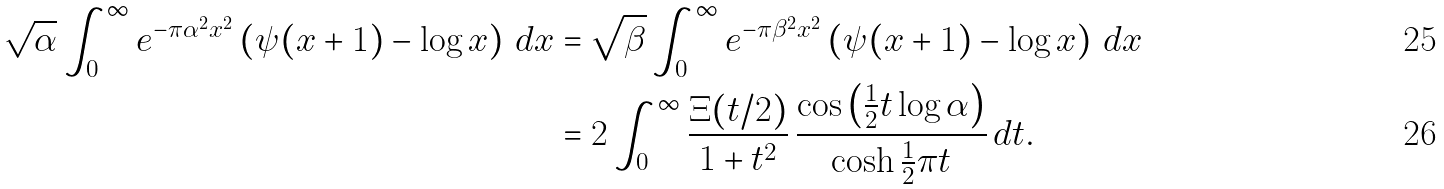Convert formula to latex. <formula><loc_0><loc_0><loc_500><loc_500>\sqrt { \alpha } \int _ { 0 } ^ { \infty } e ^ { - \pi \alpha ^ { 2 } x ^ { 2 } } \left ( \psi ( x + 1 ) - \log x \right ) \, d x & = \sqrt { \beta } \int _ { 0 } ^ { \infty } e ^ { - \pi \beta ^ { 2 } x ^ { 2 } } \left ( \psi ( x + 1 ) - \log x \right ) \, d x \\ & = 2 \int _ { 0 } ^ { \infty } \frac { \Xi ( t / 2 ) } { 1 + t ^ { 2 } } \, \frac { \cos \left ( \frac { 1 } { 2 } t \log \alpha \right ) } { \cosh \frac { 1 } { 2 } \pi t } \, d t .</formula> 